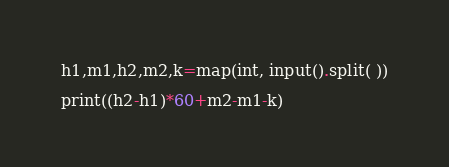Convert code to text. <code><loc_0><loc_0><loc_500><loc_500><_Python_>h1,m1,h2,m2,k=map(int, input().split( ))

print((h2-h1)*60+m2-m1-k)</code> 